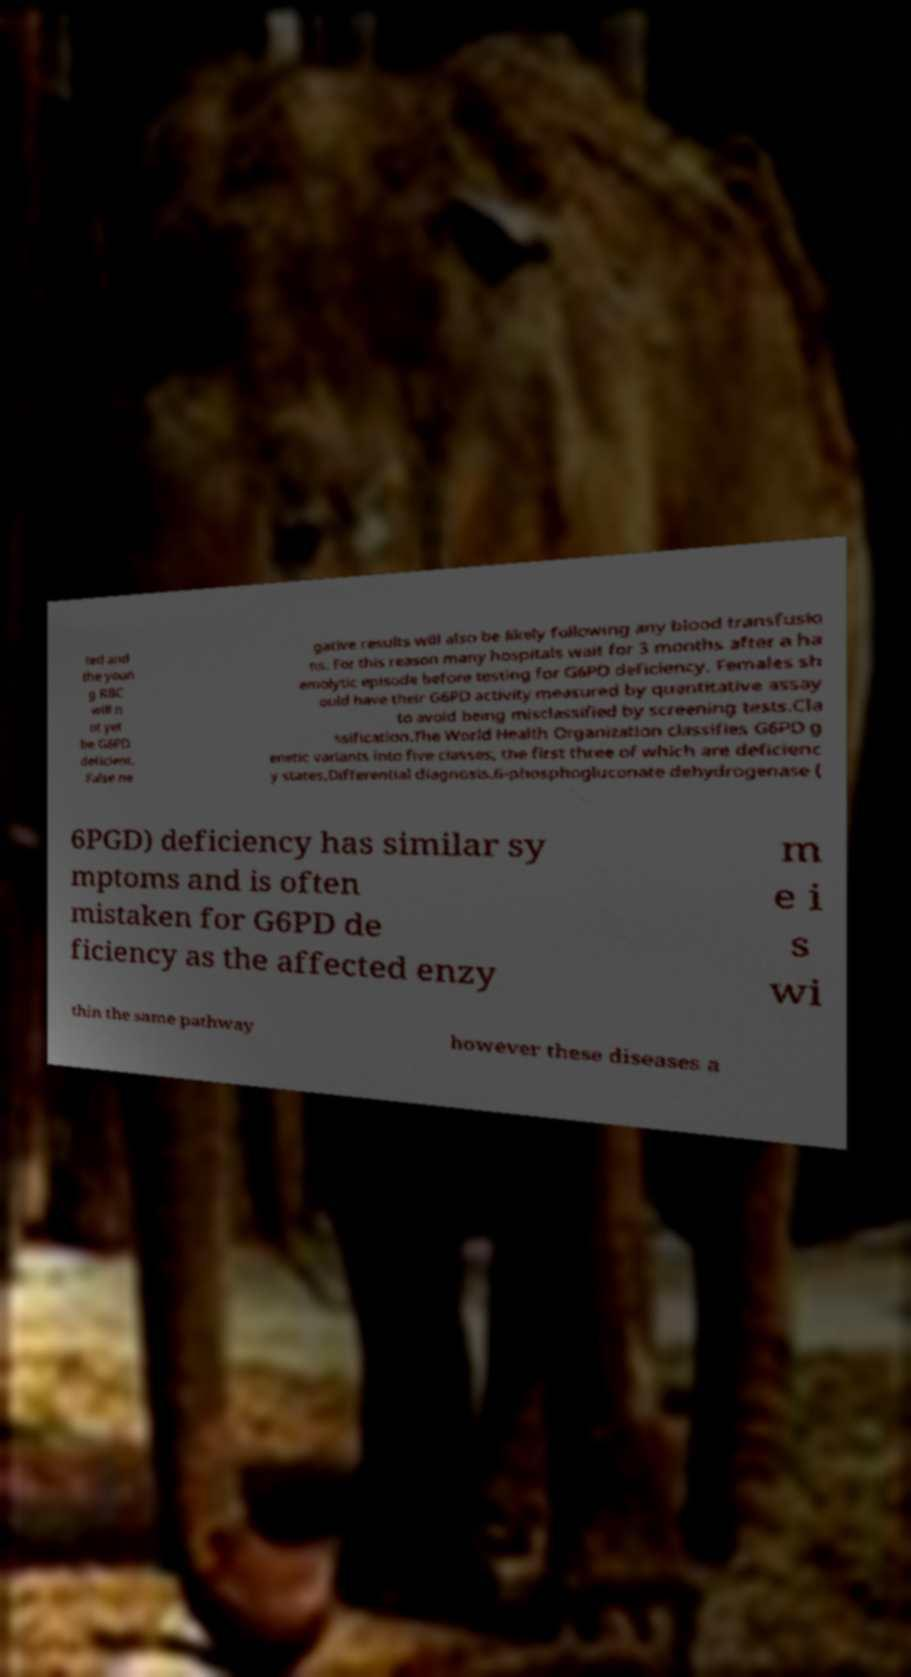For documentation purposes, I need the text within this image transcribed. Could you provide that? ted and the youn g RBC will n ot yet be G6PD deficient. False ne gative results will also be likely following any blood transfusio ns. For this reason many hospitals wait for 3 months after a ha emolytic episode before testing for G6PD deficiency. Females sh ould have their G6PD activity measured by quantitative assay to avoid being misclassified by screening tests.Cla ssification.The World Health Organization classifies G6PD g enetic variants into five classes, the first three of which are deficienc y states.Differential diagnosis.6-phosphogluconate dehydrogenase ( 6PGD) deficiency has similar sy mptoms and is often mistaken for G6PD de ficiency as the affected enzy m e i s wi thin the same pathway however these diseases a 